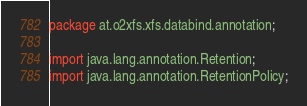<code> <loc_0><loc_0><loc_500><loc_500><_Java_>package at.o2xfs.xfs.databind.annotation;

import java.lang.annotation.Retention;
import java.lang.annotation.RetentionPolicy;
</code> 